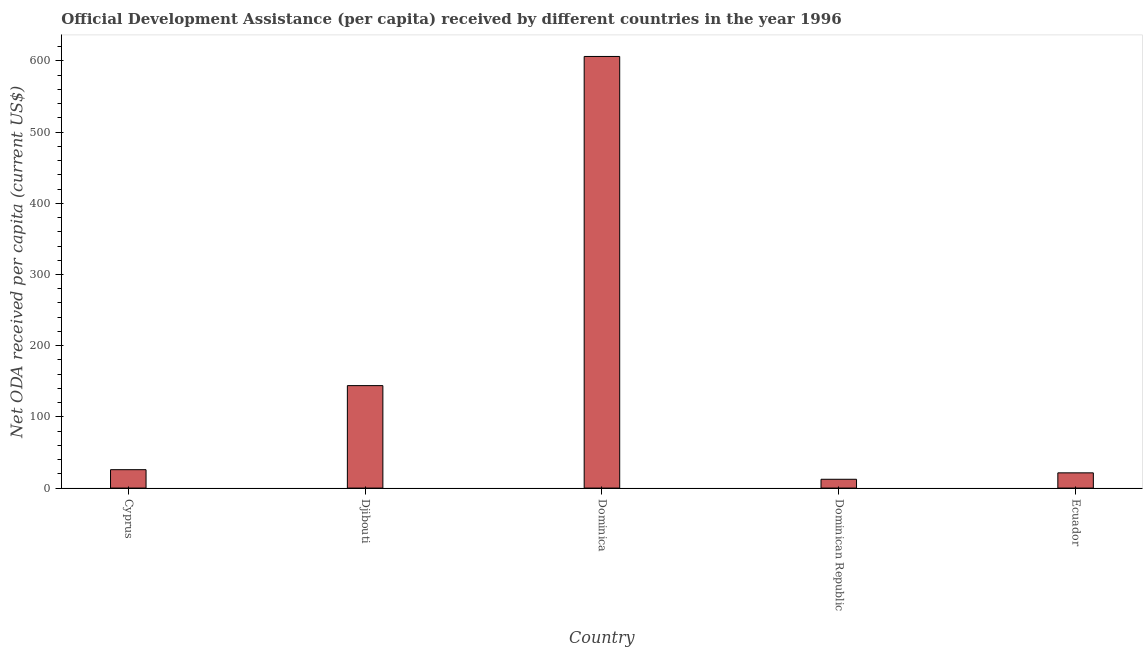Does the graph contain any zero values?
Your answer should be very brief. No. What is the title of the graph?
Your answer should be very brief. Official Development Assistance (per capita) received by different countries in the year 1996. What is the label or title of the Y-axis?
Offer a very short reply. Net ODA received per capita (current US$). What is the net oda received per capita in Ecuador?
Keep it short and to the point. 21.41. Across all countries, what is the maximum net oda received per capita?
Offer a terse response. 606.22. Across all countries, what is the minimum net oda received per capita?
Give a very brief answer. 12.39. In which country was the net oda received per capita maximum?
Ensure brevity in your answer.  Dominica. In which country was the net oda received per capita minimum?
Offer a very short reply. Dominican Republic. What is the sum of the net oda received per capita?
Your response must be concise. 809.81. What is the difference between the net oda received per capita in Cyprus and Dominica?
Make the answer very short. -580.36. What is the average net oda received per capita per country?
Ensure brevity in your answer.  161.96. What is the median net oda received per capita?
Your response must be concise. 25.86. In how many countries, is the net oda received per capita greater than 600 US$?
Give a very brief answer. 1. What is the ratio of the net oda received per capita in Cyprus to that in Dominican Republic?
Offer a terse response. 2.09. Is the net oda received per capita in Cyprus less than that in Dominican Republic?
Offer a terse response. No. Is the difference between the net oda received per capita in Cyprus and Ecuador greater than the difference between any two countries?
Your answer should be compact. No. What is the difference between the highest and the second highest net oda received per capita?
Provide a short and direct response. 462.29. What is the difference between the highest and the lowest net oda received per capita?
Provide a succinct answer. 593.82. In how many countries, is the net oda received per capita greater than the average net oda received per capita taken over all countries?
Provide a short and direct response. 1. How many bars are there?
Give a very brief answer. 5. Are all the bars in the graph horizontal?
Make the answer very short. No. How many countries are there in the graph?
Keep it short and to the point. 5. Are the values on the major ticks of Y-axis written in scientific E-notation?
Make the answer very short. No. What is the Net ODA received per capita (current US$) in Cyprus?
Keep it short and to the point. 25.86. What is the Net ODA received per capita (current US$) in Djibouti?
Make the answer very short. 143.92. What is the Net ODA received per capita (current US$) of Dominica?
Your answer should be very brief. 606.22. What is the Net ODA received per capita (current US$) in Dominican Republic?
Give a very brief answer. 12.39. What is the Net ODA received per capita (current US$) in Ecuador?
Keep it short and to the point. 21.41. What is the difference between the Net ODA received per capita (current US$) in Cyprus and Djibouti?
Offer a very short reply. -118.07. What is the difference between the Net ODA received per capita (current US$) in Cyprus and Dominica?
Keep it short and to the point. -580.36. What is the difference between the Net ODA received per capita (current US$) in Cyprus and Dominican Republic?
Your response must be concise. 13.46. What is the difference between the Net ODA received per capita (current US$) in Cyprus and Ecuador?
Your answer should be very brief. 4.44. What is the difference between the Net ODA received per capita (current US$) in Djibouti and Dominica?
Make the answer very short. -462.29. What is the difference between the Net ODA received per capita (current US$) in Djibouti and Dominican Republic?
Your answer should be very brief. 131.53. What is the difference between the Net ODA received per capita (current US$) in Djibouti and Ecuador?
Provide a short and direct response. 122.51. What is the difference between the Net ODA received per capita (current US$) in Dominica and Dominican Republic?
Keep it short and to the point. 593.82. What is the difference between the Net ODA received per capita (current US$) in Dominica and Ecuador?
Your answer should be very brief. 584.8. What is the difference between the Net ODA received per capita (current US$) in Dominican Republic and Ecuador?
Your answer should be very brief. -9.02. What is the ratio of the Net ODA received per capita (current US$) in Cyprus to that in Djibouti?
Ensure brevity in your answer.  0.18. What is the ratio of the Net ODA received per capita (current US$) in Cyprus to that in Dominica?
Provide a succinct answer. 0.04. What is the ratio of the Net ODA received per capita (current US$) in Cyprus to that in Dominican Republic?
Your answer should be compact. 2.09. What is the ratio of the Net ODA received per capita (current US$) in Cyprus to that in Ecuador?
Keep it short and to the point. 1.21. What is the ratio of the Net ODA received per capita (current US$) in Djibouti to that in Dominica?
Ensure brevity in your answer.  0.24. What is the ratio of the Net ODA received per capita (current US$) in Djibouti to that in Dominican Republic?
Provide a succinct answer. 11.61. What is the ratio of the Net ODA received per capita (current US$) in Djibouti to that in Ecuador?
Provide a short and direct response. 6.72. What is the ratio of the Net ODA received per capita (current US$) in Dominica to that in Dominican Republic?
Your response must be concise. 48.91. What is the ratio of the Net ODA received per capita (current US$) in Dominica to that in Ecuador?
Your answer should be very brief. 28.31. What is the ratio of the Net ODA received per capita (current US$) in Dominican Republic to that in Ecuador?
Offer a very short reply. 0.58. 